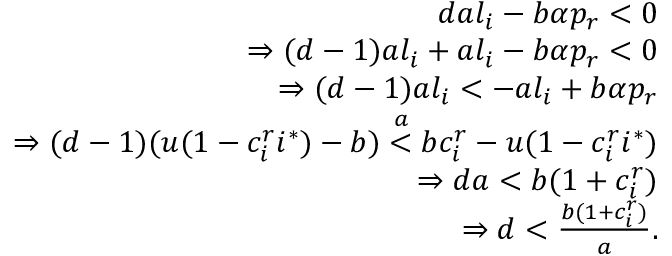Convert formula to latex. <formula><loc_0><loc_0><loc_500><loc_500>\begin{array} { r } { d a l _ { i } - b \alpha p _ { r } < 0 } \\ { \Rightarrow ( d - 1 ) a l _ { i } + a l _ { i } - b \alpha p _ { r } < 0 } \\ { \Rightarrow ( d - 1 ) a l _ { i } < - a l _ { i } + b \alpha p _ { r } } \\ { \Rightarrow ( d - 1 ) ( u ( 1 - c _ { i } ^ { r } i ^ { * } ) - b ) \stackrel { a } { < } b c _ { i } ^ { r } - u ( 1 - c _ { i } ^ { r } i ^ { * } ) } \\ { \Rightarrow d a < b ( 1 + c _ { i } ^ { r } ) } \\ { \Rightarrow d < \frac { b ( 1 + c _ { i } ^ { r } ) } { a } . } \end{array}</formula> 